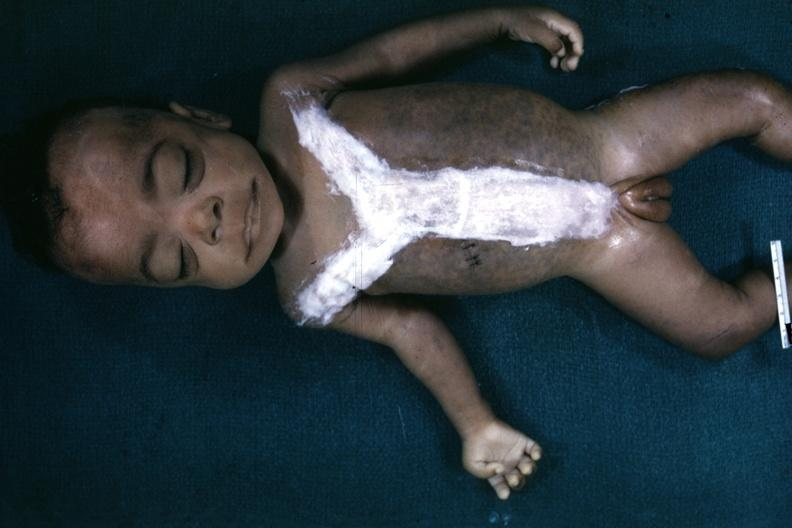how many hand does this image show whole body after autopsy with covered incision very good representation of mongoloid facies and is opened to show simian crease quite good example?
Answer the question using a single word or phrase. One 